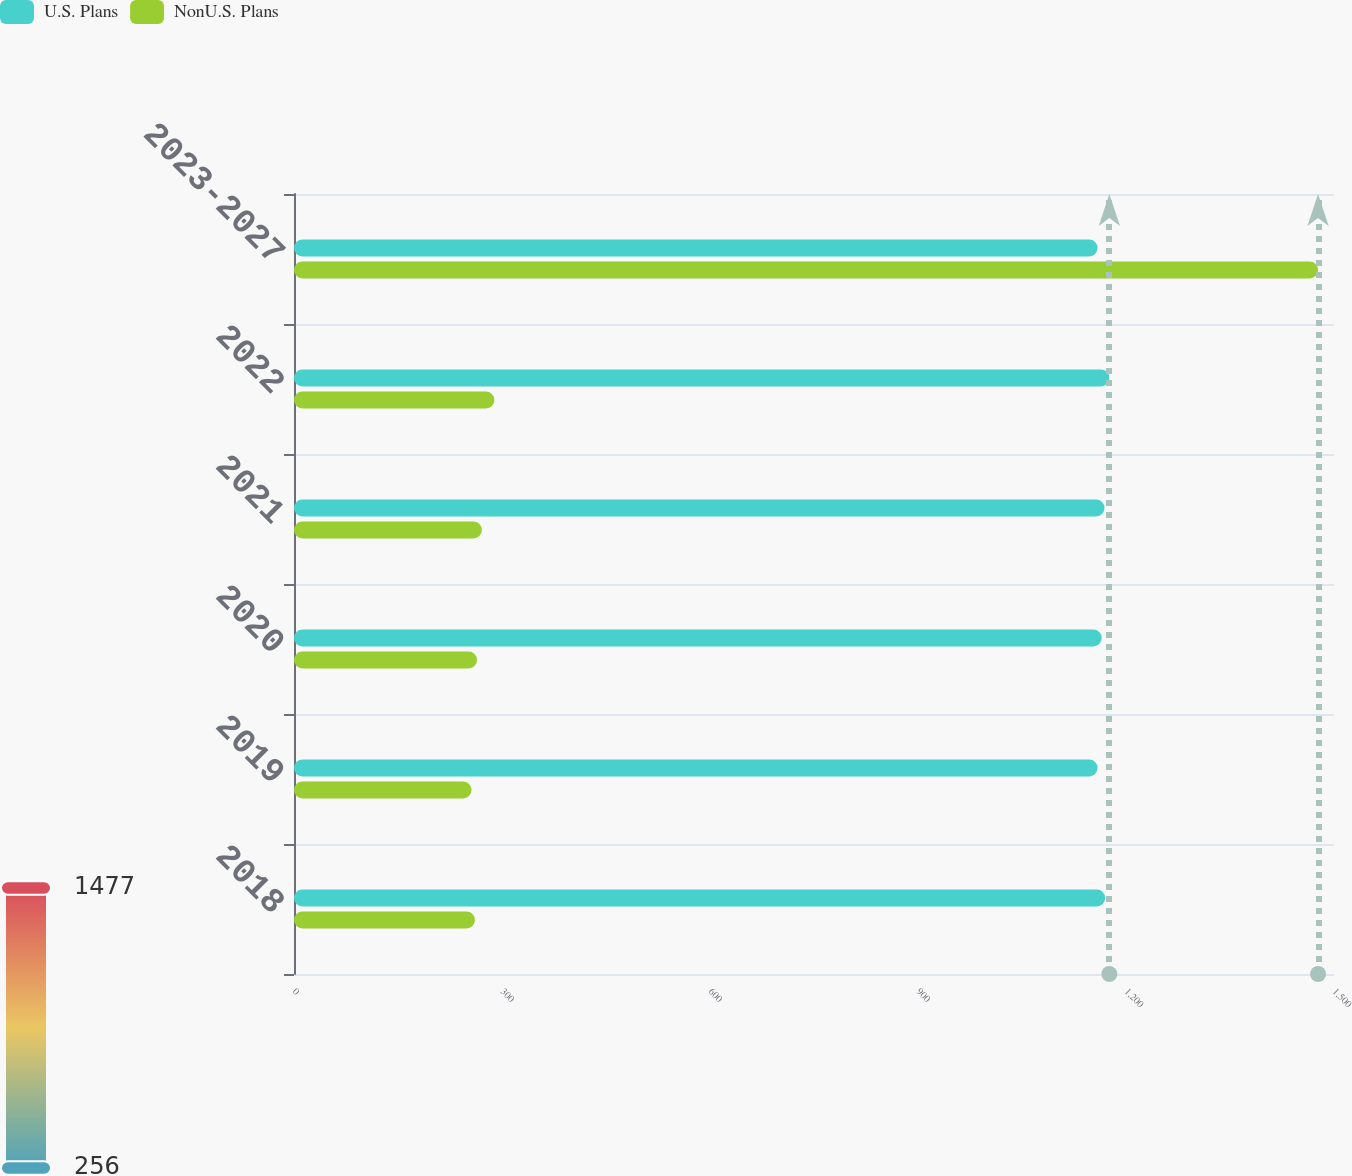Convert chart to OTSL. <chart><loc_0><loc_0><loc_500><loc_500><stacked_bar_chart><ecel><fcel>2018<fcel>2019<fcel>2020<fcel>2021<fcel>2022<fcel>2023-2027<nl><fcel>U.S. Plans<fcel>1170<fcel>1159<fcel>1165<fcel>1169<fcel>1176<fcel>1159<nl><fcel>NonU.S. Plans<fcel>261<fcel>256<fcel>264<fcel>271<fcel>289<fcel>1477<nl></chart> 